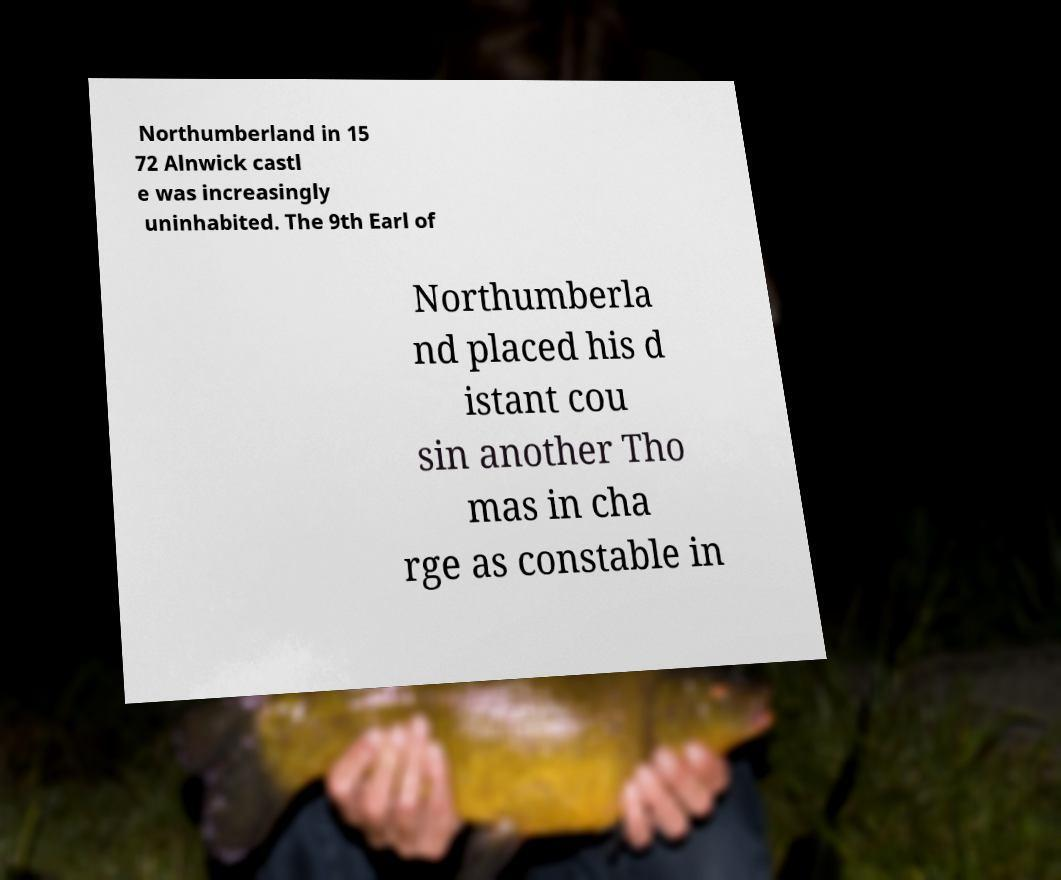Could you extract and type out the text from this image? Northumberland in 15 72 Alnwick castl e was increasingly uninhabited. The 9th Earl of Northumberla nd placed his d istant cou sin another Tho mas in cha rge as constable in 